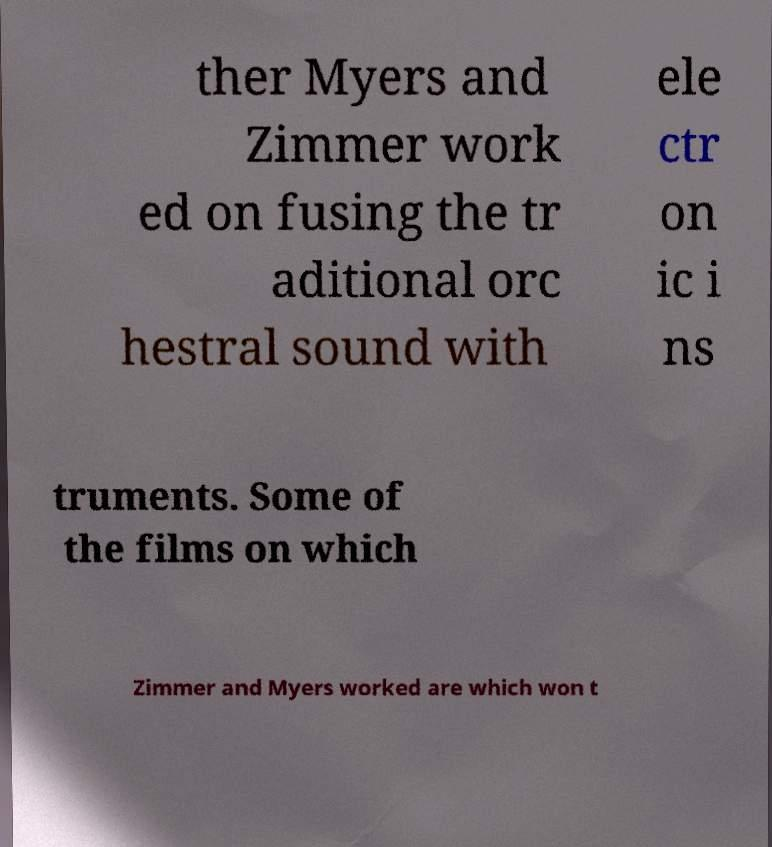Could you extract and type out the text from this image? ther Myers and Zimmer work ed on fusing the tr aditional orc hestral sound with ele ctr on ic i ns truments. Some of the films on which Zimmer and Myers worked are which won t 